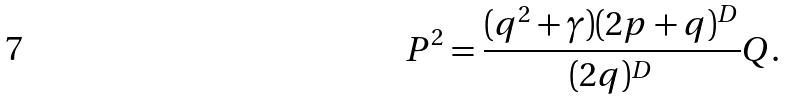Convert formula to latex. <formula><loc_0><loc_0><loc_500><loc_500>P ^ { 2 } = \frac { ( q ^ { 2 } + \gamma ) ( 2 p + q ) ^ { D } } { ( 2 q ) ^ { D } } Q .</formula> 